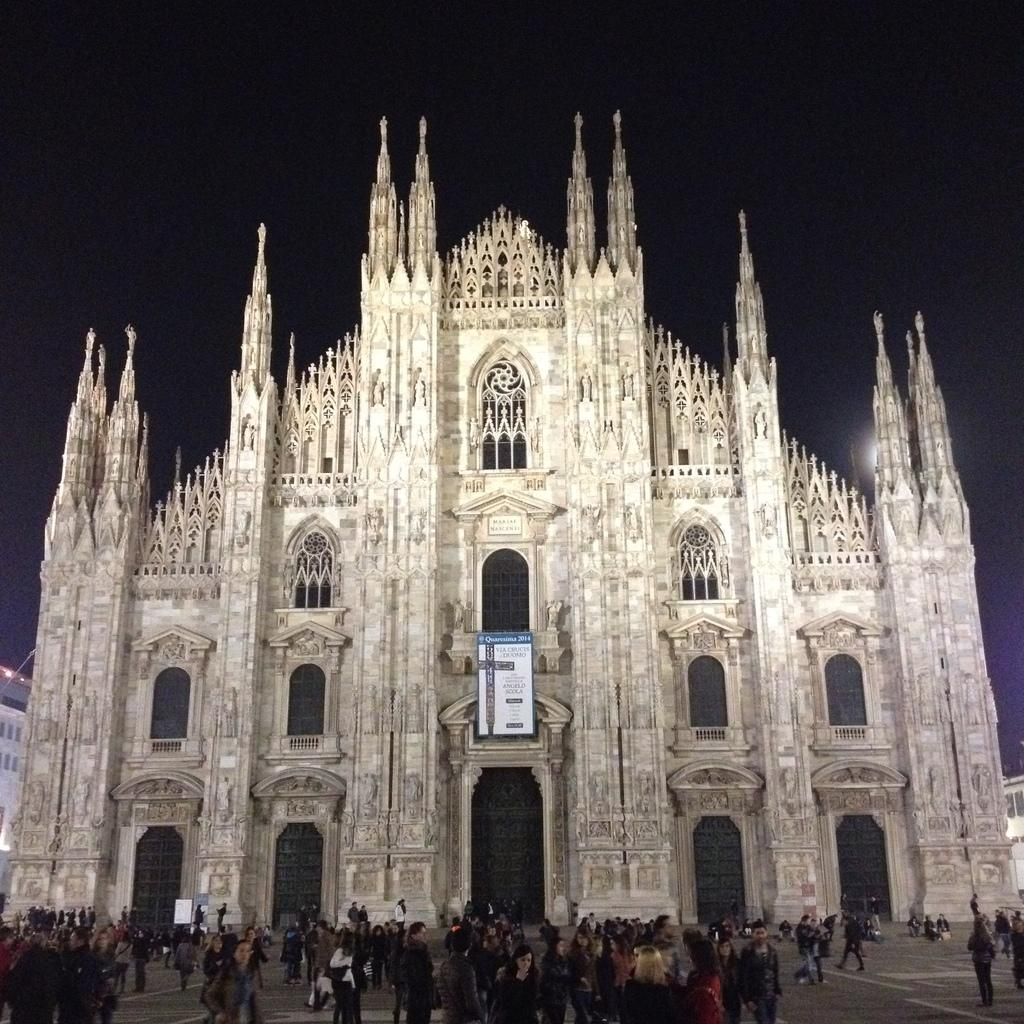What is happening on the road in the image? There are people on the road in the image. What can be seen in the background of the image? There is a building in the background of the image. What is the board in the image used for? The purpose of the board in the image is not specified, but it is visible. What is visible at the top of the image? The sky is visible at the top of the image. Is there a bomb visible in the image? No, there is no bomb present in the image. What type of railway is shown in the image? There is no railway present in the image; it features people on a road with a building in the background. 